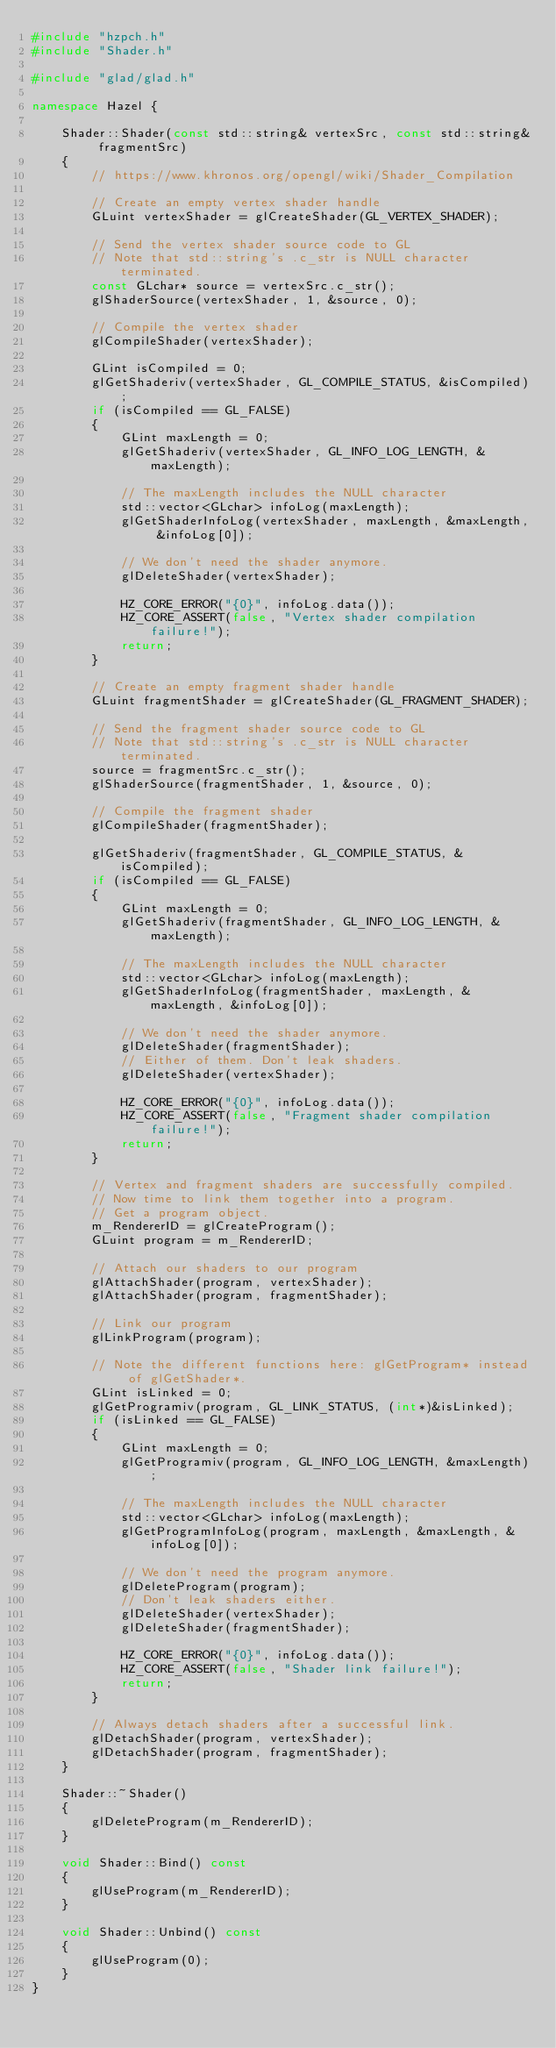<code> <loc_0><loc_0><loc_500><loc_500><_C++_>#include "hzpch.h"
#include "Shader.h"

#include "glad/glad.h"

namespace Hazel {

	Shader::Shader(const std::string& vertexSrc, const std::string& fragmentSrc)
	{
		// https://www.khronos.org/opengl/wiki/Shader_Compilation

		// Create an empty vertex shader handle
		GLuint vertexShader = glCreateShader(GL_VERTEX_SHADER);

		// Send the vertex shader source code to GL
		// Note that std::string's .c_str is NULL character terminated.
		const GLchar* source = vertexSrc.c_str();
		glShaderSource(vertexShader, 1, &source, 0);

		// Compile the vertex shader
		glCompileShader(vertexShader);

		GLint isCompiled = 0;
		glGetShaderiv(vertexShader, GL_COMPILE_STATUS, &isCompiled);
		if (isCompiled == GL_FALSE)
		{
			GLint maxLength = 0;
			glGetShaderiv(vertexShader, GL_INFO_LOG_LENGTH, &maxLength);

			// The maxLength includes the NULL character
			std::vector<GLchar> infoLog(maxLength);
			glGetShaderInfoLog(vertexShader, maxLength, &maxLength, &infoLog[0]);

			// We don't need the shader anymore.
			glDeleteShader(vertexShader);

			HZ_CORE_ERROR("{0}", infoLog.data());
			HZ_CORE_ASSERT(false, "Vertex shader compilation failure!");
			return;
		}

		// Create an empty fragment shader handle
		GLuint fragmentShader = glCreateShader(GL_FRAGMENT_SHADER);

		// Send the fragment shader source code to GL
		// Note that std::string's .c_str is NULL character terminated.
		source = fragmentSrc.c_str();
		glShaderSource(fragmentShader, 1, &source, 0);

		// Compile the fragment shader
		glCompileShader(fragmentShader);

		glGetShaderiv(fragmentShader, GL_COMPILE_STATUS, &isCompiled);
		if (isCompiled == GL_FALSE)
		{
			GLint maxLength = 0;
			glGetShaderiv(fragmentShader, GL_INFO_LOG_LENGTH, &maxLength);

			// The maxLength includes the NULL character
			std::vector<GLchar> infoLog(maxLength);
			glGetShaderInfoLog(fragmentShader, maxLength, &maxLength, &infoLog[0]);

			// We don't need the shader anymore.
			glDeleteShader(fragmentShader);
			// Either of them. Don't leak shaders.
			glDeleteShader(vertexShader);

			HZ_CORE_ERROR("{0}", infoLog.data());
			HZ_CORE_ASSERT(false, "Fragment shader compilation failure!");
			return;
		}

		// Vertex and fragment shaders are successfully compiled.
		// Now time to link them together into a program.
		// Get a program object.
		m_RendererID = glCreateProgram();
		GLuint program = m_RendererID;

		// Attach our shaders to our program
		glAttachShader(program, vertexShader);
		glAttachShader(program, fragmentShader);

		// Link our program
		glLinkProgram(program);

		// Note the different functions here: glGetProgram* instead of glGetShader*.
		GLint isLinked = 0;
		glGetProgramiv(program, GL_LINK_STATUS, (int*)&isLinked);
		if (isLinked == GL_FALSE)
		{
			GLint maxLength = 0;
			glGetProgramiv(program, GL_INFO_LOG_LENGTH, &maxLength);

			// The maxLength includes the NULL character
			std::vector<GLchar> infoLog(maxLength);
			glGetProgramInfoLog(program, maxLength, &maxLength, &infoLog[0]);

			// We don't need the program anymore.
			glDeleteProgram(program);
			// Don't leak shaders either.
			glDeleteShader(vertexShader);
			glDeleteShader(fragmentShader);

			HZ_CORE_ERROR("{0}", infoLog.data());
			HZ_CORE_ASSERT(false, "Shader link failure!");
			return;
		}

		// Always detach shaders after a successful link.
		glDetachShader(program, vertexShader);
		glDetachShader(program, fragmentShader);
	}

	Shader::~Shader()
	{
		glDeleteProgram(m_RendererID);
	}

	void Shader::Bind() const
	{
		glUseProgram(m_RendererID);
	}

	void Shader::Unbind() const
	{
		glUseProgram(0);
	}
}</code> 